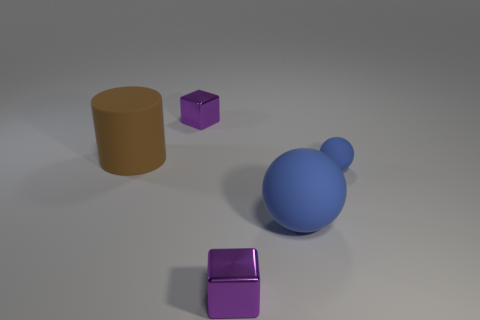How many objects are small purple shiny blocks behind the large blue object or matte balls?
Keep it short and to the point. 3. Is there a large thing that has the same color as the big matte ball?
Keep it short and to the point. No. Do the large brown object and the small blue rubber object in front of the brown matte object have the same shape?
Offer a very short reply. No. What number of things are both left of the small matte thing and right of the brown matte object?
Make the answer very short. 3. There is another blue thing that is the same shape as the big blue object; what is its material?
Your answer should be compact. Rubber. How big is the thing that is in front of the ball that is in front of the tiny blue object?
Ensure brevity in your answer.  Small. Is there a large yellow metallic thing?
Offer a terse response. No. What material is the object that is behind the big blue matte ball and in front of the large brown matte cylinder?
Your answer should be very brief. Rubber. Is the number of large blue matte things that are on the right side of the big brown rubber cylinder greater than the number of small matte things behind the small blue ball?
Provide a succinct answer. Yes. Are there any matte balls that have the same size as the brown rubber object?
Your response must be concise. Yes. 